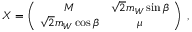Convert formula to latex. <formula><loc_0><loc_0><loc_500><loc_500>X = \left ( \, \begin{array} { c c } { M } & { { \sqrt { 2 } m _ { W } \sin \beta } } \\ { { \sqrt { 2 } m _ { W } \cos \beta } } & { \mu } \end{array} \, \right ) \, ,</formula> 